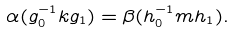<formula> <loc_0><loc_0><loc_500><loc_500>\alpha ( g _ { 0 } ^ { - 1 } k g _ { 1 } ) = \beta ( h _ { 0 } ^ { - 1 } m h _ { 1 } ) .</formula> 